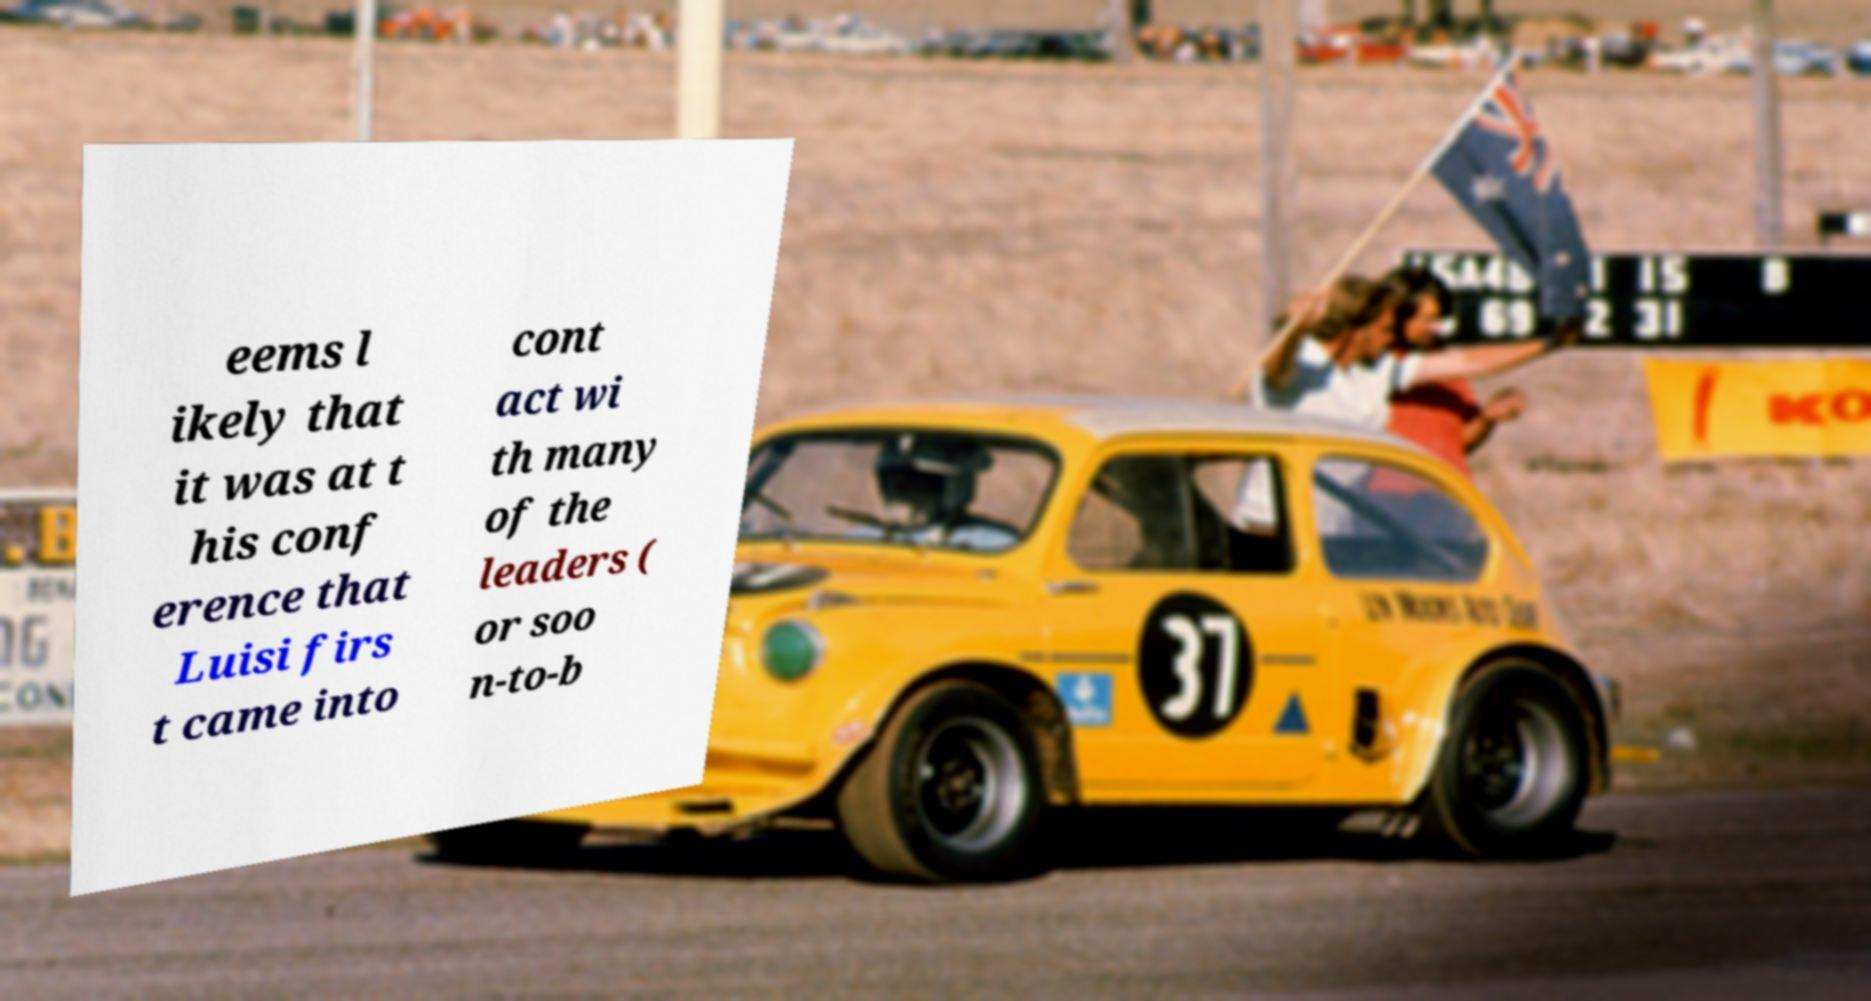Could you extract and type out the text from this image? eems l ikely that it was at t his conf erence that Luisi firs t came into cont act wi th many of the leaders ( or soo n-to-b 